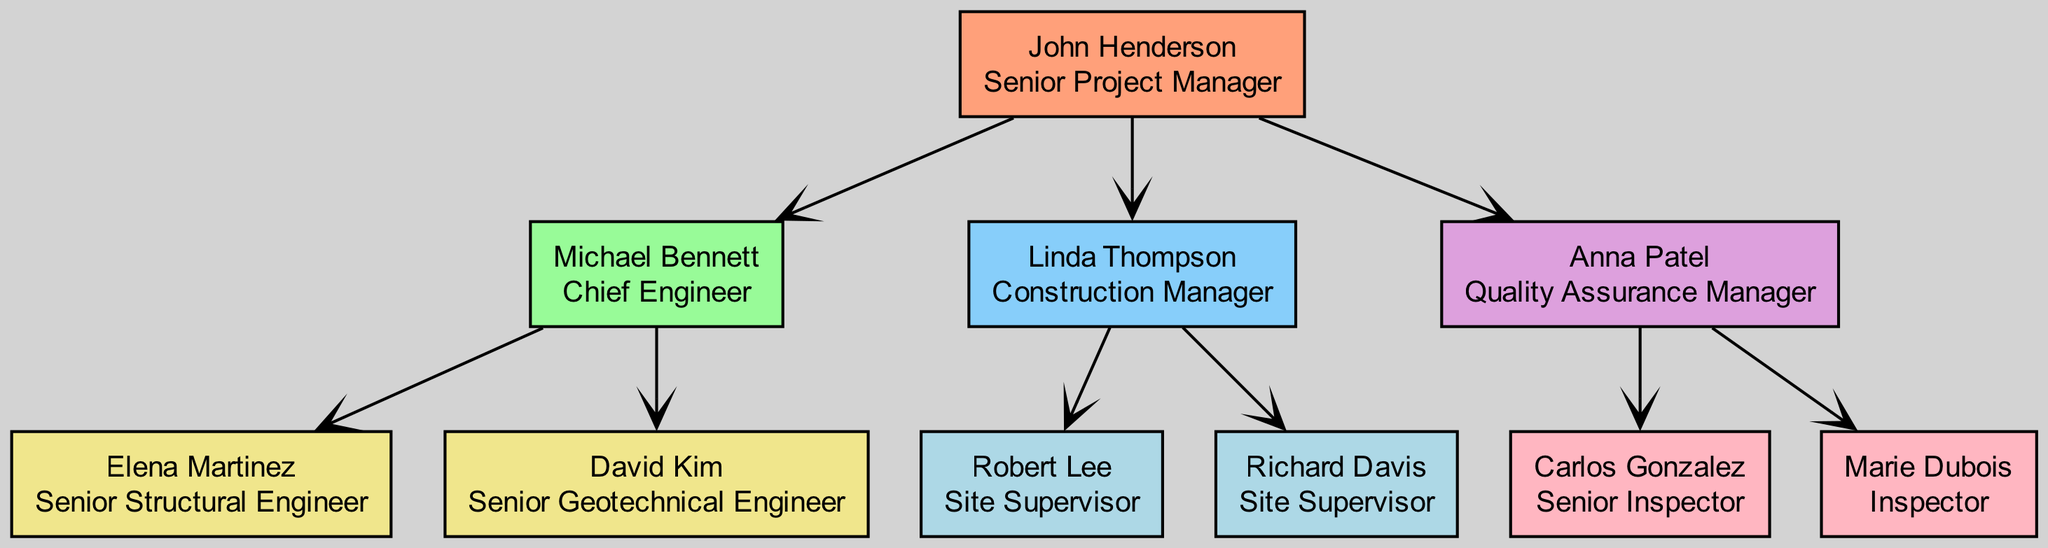What is the name of the Project Lead? The Project Lead is named John Henderson, as indicated at the top of the diagram where he is identified with his role as Senior Project Manager.
Answer: John Henderson How many subordinates report directly to the Project Lead? The Project Lead has three direct subordinates: Engineering Lead, Construction Lead, and Quality Assurance Lead. This can be counted directly from the subordinates listed under John Henderson.
Answer: 3 Who is the Chief Engineer? The Chief Engineer is Michael Bennett, who is listed as a subordinate of John Henderson under the Engineering Lead section.
Answer: Michael Bennett Which role does Elena Martinez hold? Elena Martinez is classified as a Senior Structural Engineer. This is found in the node that details her information beneath the Engineering Lead, Michael Bennett.
Answer: Senior Structural Engineer What is the relationship between Anna Patel and John Henderson? Anna Patel is the Quality Assurance Manager, reporting directly to John Henderson, showing a supervisor-employee relationship in the hierarchy.
Answer: Supervisor-Employee How many Site Supervisors are in the project team? There are two Site Supervisors listed under the Construction Lead: Robert Lee and Richard Davis. This can be deduced by counting the subordinates under Linda Thompson.
Answer: 2 Which node is the last in the hierarchy below the Engineering Lead? The last nodes below the Engineering Lead are the roles of Elena Martinez and David Kim. Both are the only subordinates to Michael Bennett.
Answer: Elena Martinez and David Kim What is the role of Carlos Gonzalez in the project team? Carlos Gonzalez is identified as the Senior Inspector, found in the subordinate details under Anna Patel, the Quality Assurance Manager.
Answer: Senior Inspector Which role has the highest position in the diagram? The highest position in the diagram is held by John Henderson, who is the Senior Project Manager and leads the entire project team.
Answer: Senior Project Manager 